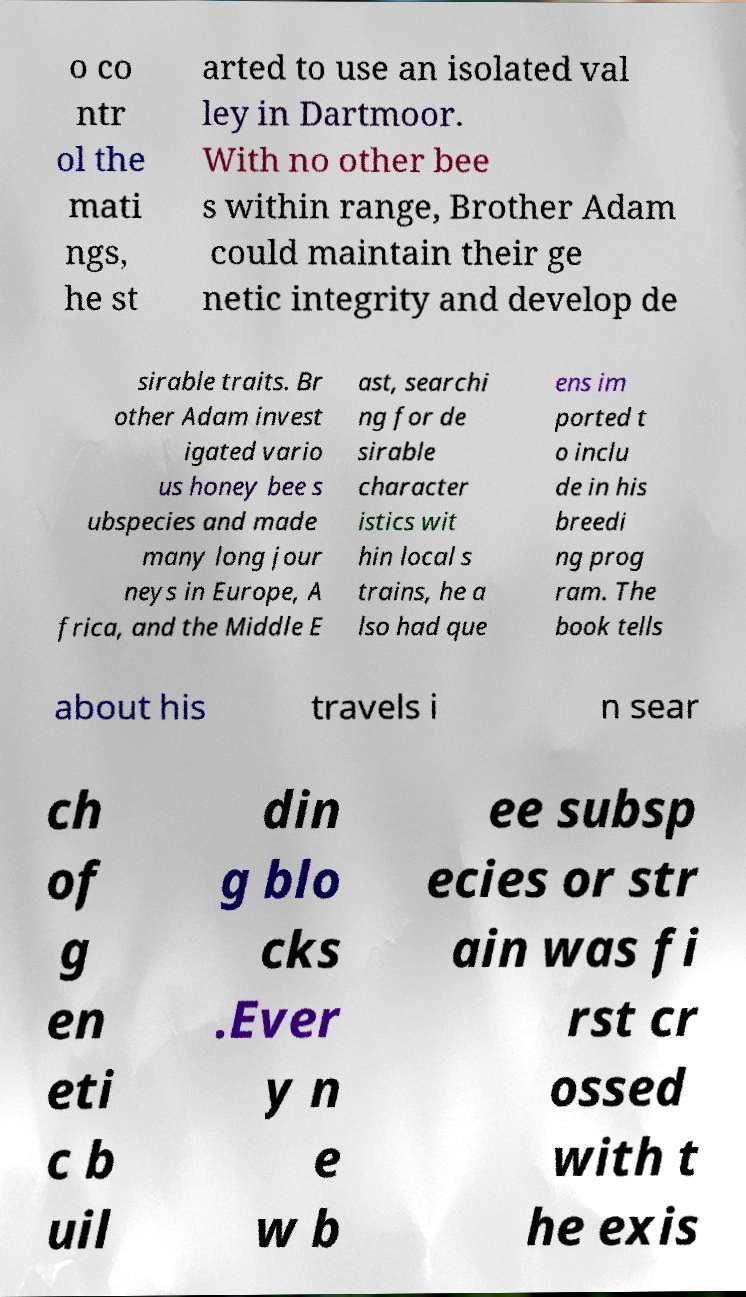Could you extract and type out the text from this image? o co ntr ol the mati ngs, he st arted to use an isolated val ley in Dartmoor. With no other bee s within range, Brother Adam could maintain their ge netic integrity and develop de sirable traits. Br other Adam invest igated vario us honey bee s ubspecies and made many long jour neys in Europe, A frica, and the Middle E ast, searchi ng for de sirable character istics wit hin local s trains, he a lso had que ens im ported t o inclu de in his breedi ng prog ram. The book tells about his travels i n sear ch of g en eti c b uil din g blo cks .Ever y n e w b ee subsp ecies or str ain was fi rst cr ossed with t he exis 